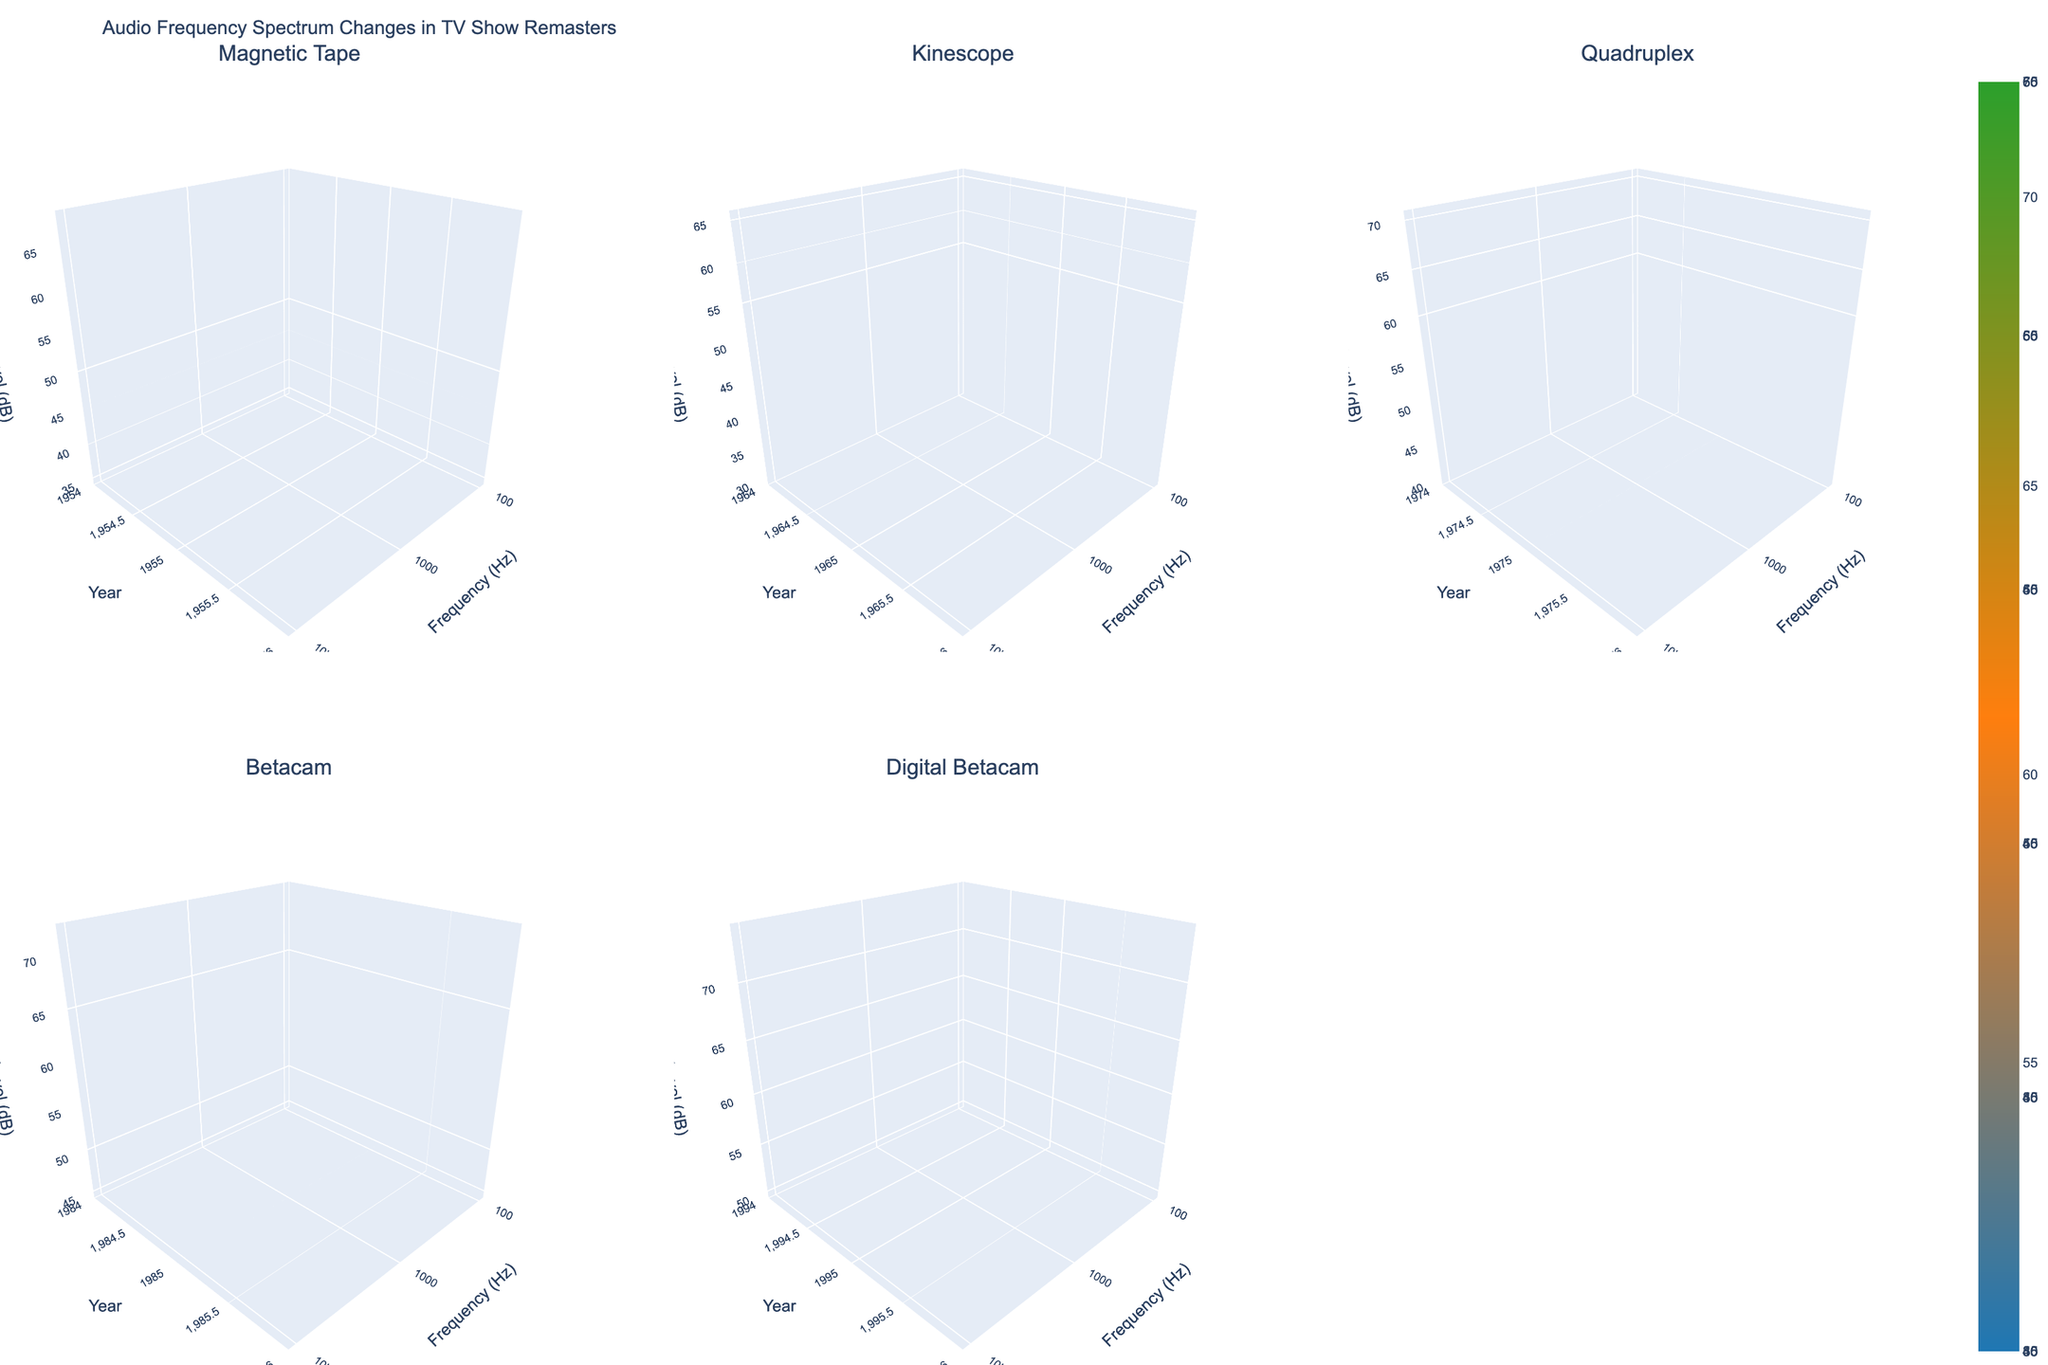What is the title of the figure? The title is displayed at the top of the figure, showing a description of the plot's subject matter.
Answer: Audio Frequency Spectrum Changes in TV Show Remasters What is the color scale used in the figure? The colors range from blue for lower levels, through orange, to green for higher levels. This color gradient allows you to easily distinguish between different level values.
Answer: From blue to orange to green How many subplots are there and what do they represent? There are six subplots, each representing a different recording technology (Magnetic Tape, Kinescope, Quadruplex, Betacam, and Digital Betacam), grouped by the release year and frequency range.
Answer: Six subplots by recording technology What axes are used in each subplot and what do they represent? The x-axis represents Frequency (Hz), the y-axis represents Year, and the z-axis represents Level (dB). These axes help to visualize how the audio frequency spectrum changes over time for different technologies.
Answer: Frequency (Hz), Year, Level (dB) Which recording technology shows the highest improvement in audio levels after remastering in the 10000 Hz range? To find the highest improvement, compare the height difference between the original and remastered surfaces at 10000 Hz across all subplots. The Digital Betacam technology shows the highest improvement in the 10000 Hz range.
Answer: Digital Betacam At 100 Hz, which year shows the least difference in levels between original and remastered for the Magnetic Tape technology? Examine the 100 Hz line for the Magnetic Tape subplot and observe which year shows the smallest vertical gap between the original and remastered surfaces. The year with the least difference is 1985.
Answer: 1985 What is the general trend observed in the remastered levels across all technologies? Look at the overall pattern of the remastered surfaces across all subplots. There is a general upward trend, indicating that remastered levels generally improve over time across all technologies.
Answer: Upwards trend over time In which frequency range and recording technology is there the smallest improvement after remastering in 1965? Check the 1965 year on all subplots and look for the smallest difference between the original and remastered surfaces. The smallest improvement is seen in the Kinescope technology at 1000 Hz.
Answer: Kinescope at 1000 Hz How does the remastered level at 1000 Hz in 1975 for Quadruplex compare to the original level in the same condition? Compare the z-values of the original and remastered surfaces at 1000 Hz and for the year 1975 in the Quadruplex subplot. The remastered level is higher than the original level.
Answer: Higher than original level 